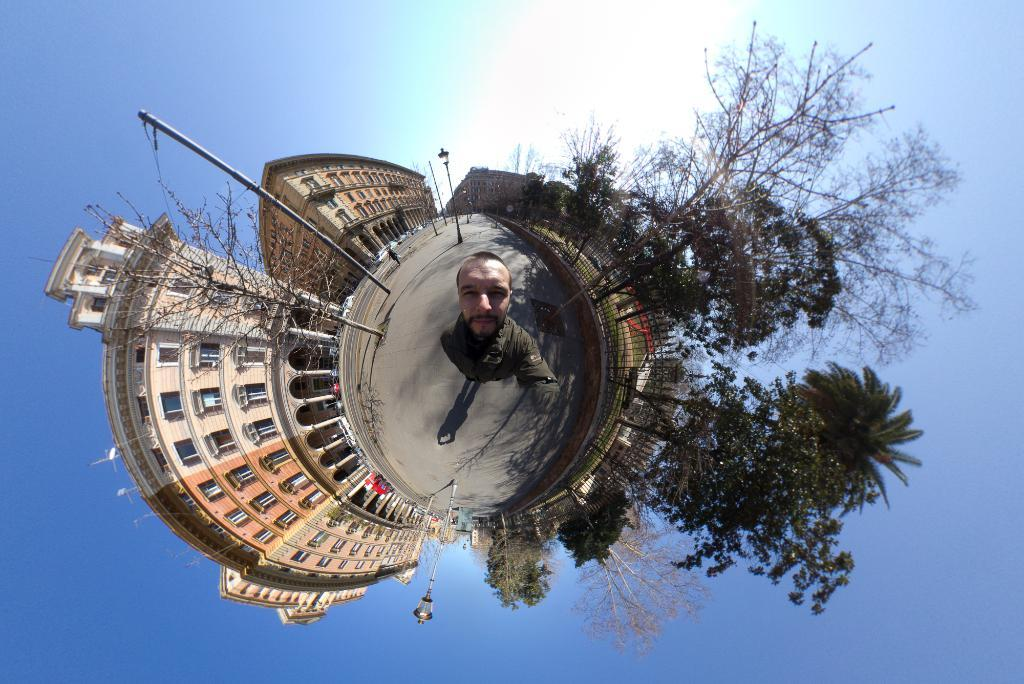What is the main subject of the image? There is a person standing in the image. What type of structures can be seen in the image? There are buildings in the image. What other natural elements are present in the image? There are trees in the image. What man-made objects can be seen in the image? There are poles in the image. What are the lights in the image used for? The lights in the image are likely used for illumination. What can be seen in the background of the image? The sky is visible in the background of the image. What type of square behavior does the person exhibit in the image? There is no mention of a square or any specific behavior in the image. The person is simply standing. 